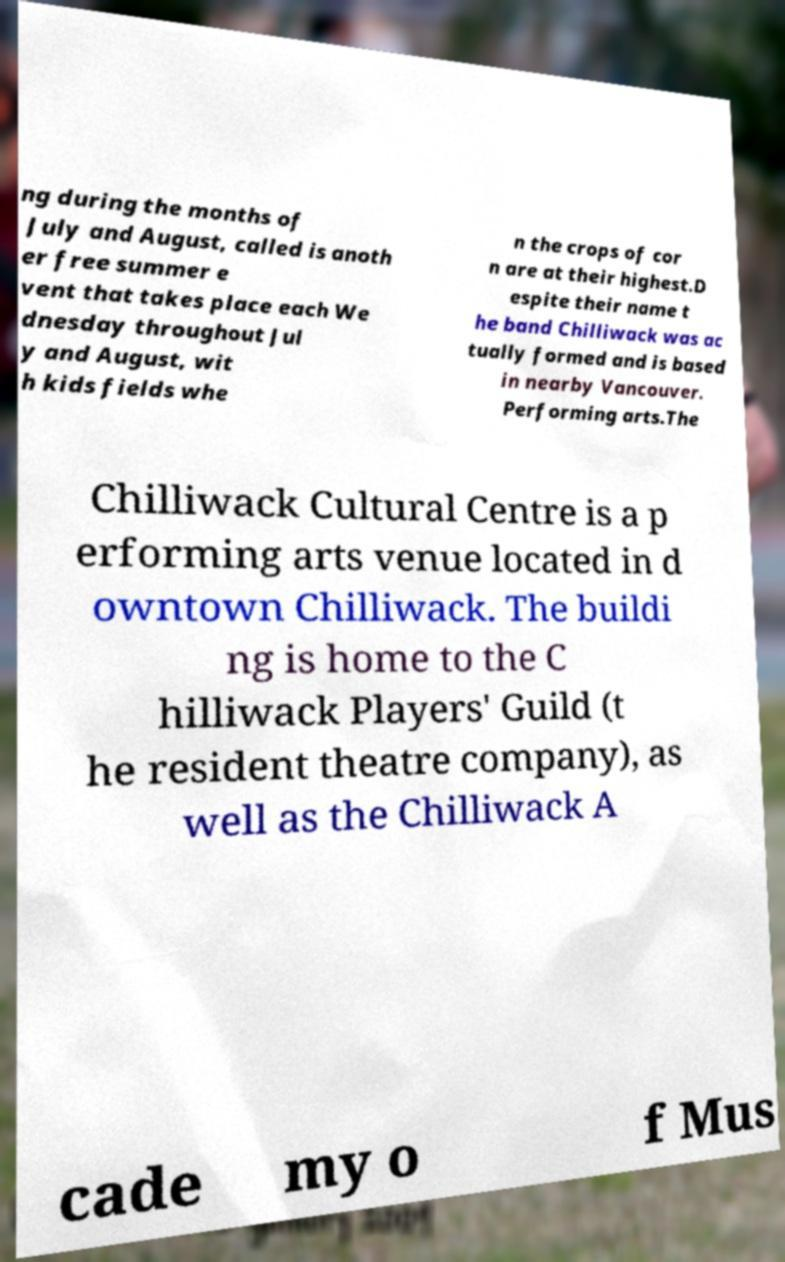Please identify and transcribe the text found in this image. ng during the months of July and August, called is anoth er free summer e vent that takes place each We dnesday throughout Jul y and August, wit h kids fields whe n the crops of cor n are at their highest.D espite their name t he band Chilliwack was ac tually formed and is based in nearby Vancouver. Performing arts.The Chilliwack Cultural Centre is a p erforming arts venue located in d owntown Chilliwack. The buildi ng is home to the C hilliwack Players' Guild (t he resident theatre company), as well as the Chilliwack A cade my o f Mus 